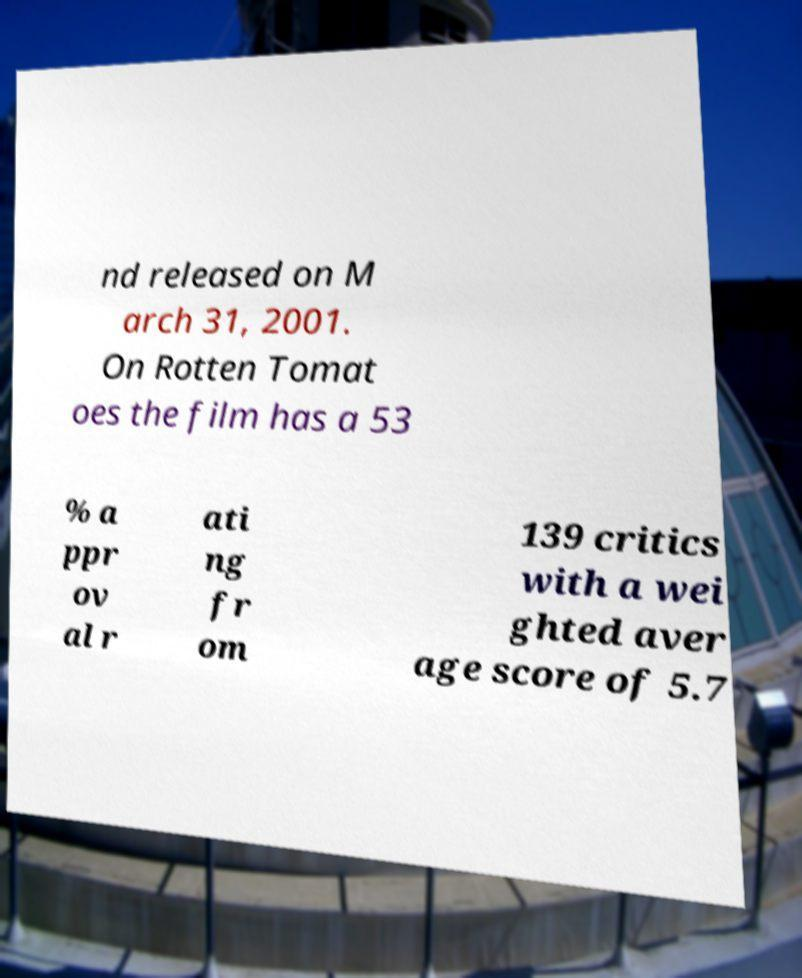What messages or text are displayed in this image? I need them in a readable, typed format. nd released on M arch 31, 2001. On Rotten Tomat oes the film has a 53 % a ppr ov al r ati ng fr om 139 critics with a wei ghted aver age score of 5.7 